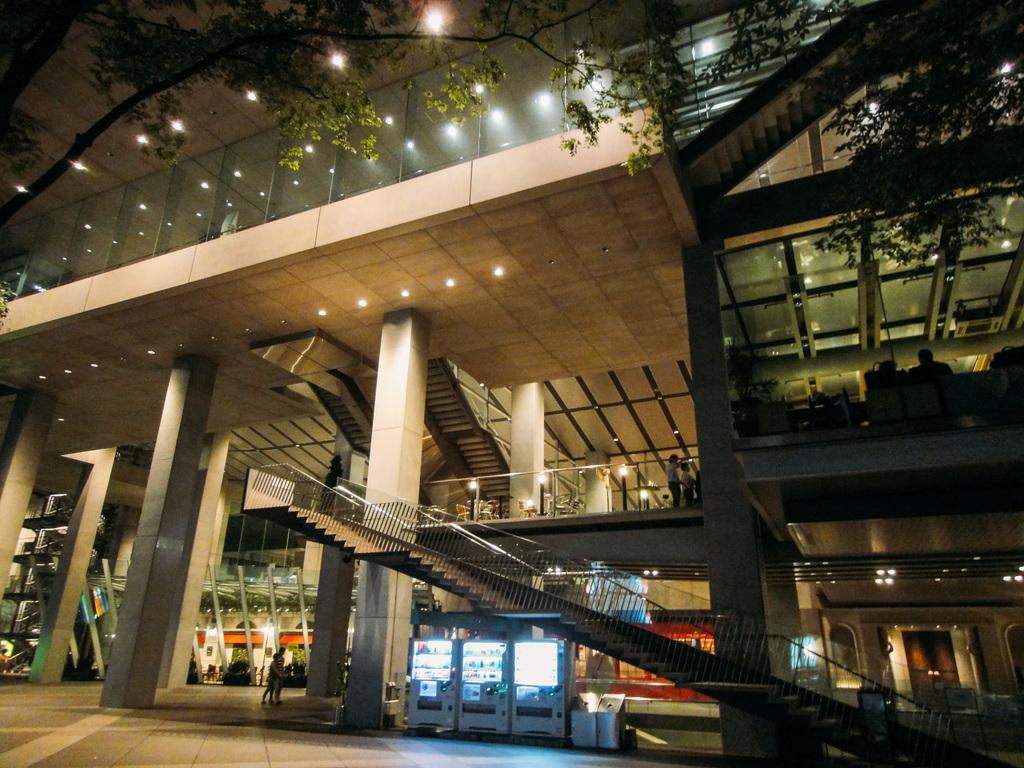Please provide a concise description of this image. In this image I can see a building and in the front of it I can see stairs. On the bottom side of the image I can see few white colour things. I can also see number of lights on the top, in the centre and on the right side of this image. I can also see few people on the bottom and on the right side of this image. On the top side of this image I can see few trees. 